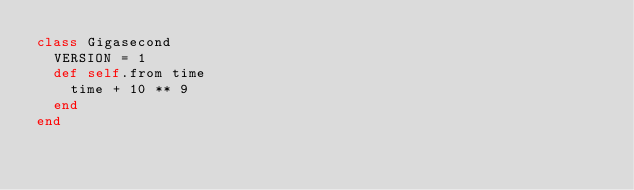Convert code to text. <code><loc_0><loc_0><loc_500><loc_500><_Ruby_>class Gigasecond
	VERSION = 1
	def self.from time
		time + 10 ** 9
	end
end</code> 